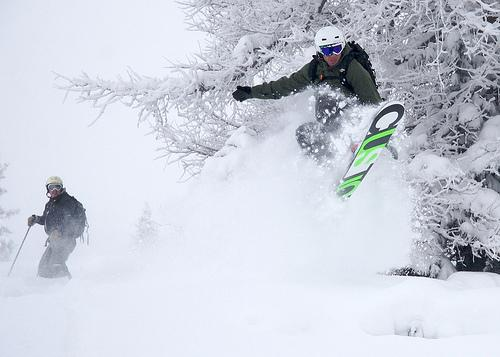How many people are present in the image, and provide a brief description of what they are doing. Two people; one man snowboarding in the air, and another man standing on the ground holding ski poles. Describe the snowboard's design and colors, and any words or letters on it. The snowboard is white, black, and green, with green and black letters on its bottom. What is the color and type of gloves worn by the man in the image? Green and black ski gloves. What type of footwear is attached to the man's feet, and what are its colors? A snowboard with white, black, and green colors. Identify the main activity taking place in the image and the person performing it. A man snowboarding on a mountain, performing a trick in the air. List any noticeable objects in the air in the image. A cloud of snow and a snowboarder through kicked-up snow. What kind of tree is covered with snow in the image? A large pine tree covered in ice and snow. What are the primary colors of the snowboarder's outfit and accessories? Green jacket, white helmet, blue goggles, black backpack, and green and black gloves. Explain how the man snowboarding is maintaining his balance. By stretching one hand out and having the snowboard attached to his feet. Briefly describe the setting and weather condition in the image. A snow-covered mountain with overcast skies in winter and snow-covered trees. How is the snowboard affixed? It is attached to the man's feet. Which item does the man wear on his head? A white ski helmet Attend to the man's attire and describe any visible additions meant for safety or protection. The man wears a white safety helmet, blue goggles, and a green and black glove on his hand. Combine elements from the image to create a multiline poem celebrating snowboarding. Man on snowboard in the wintery air, Describe the color of the gloves on the man's hand. Green and black What season is it in the image? Winter Examine the text on the snowboard and describe its appearances. The bottom of the snowboard shows green and black letters. Identify the man's snowboard colors and design. White, black, green, with green, and black letters. What is the color of the helmet? White Which of these best describes the activity in the image? a) Man skiing, b) Man snowboarding, c) Man playing basketball, d) Man scuba diving b) Man snowboarding What color are the goggles wore by the person? Blue What can be said about the trees in the scene? They are covered in snow and ice. Inform about the accessories the skier possesses. The skier has a black backpack, black ski gloves, and is holding a black ski pole. Provide a vivid description of the scene, including details about the location, season, and weather. It is a snowy winter day on a mountain, with snow covering the ground, pine trees, and tree limbs. The sky is overcast, and there is a cloud of snow in the air. Analyze the scene to determine the main activity taking place. A snowboarder catching air and performing a trick. What is happening with the snow-border?  The snowboarder is in the air, kicking up snow and performing a trick. Detail the aspects of the man's outfit that aid in the cold weather. He has a white helmet, blue goggles, green and black gloves, and is dressed in a green jacket and black coat. Visualize the snow-covered landscape and describe any unique features. Large tree covered in ice and snow, snow-covered floor, snow covered pine tree, and snow kicked up by the snowboarder. 